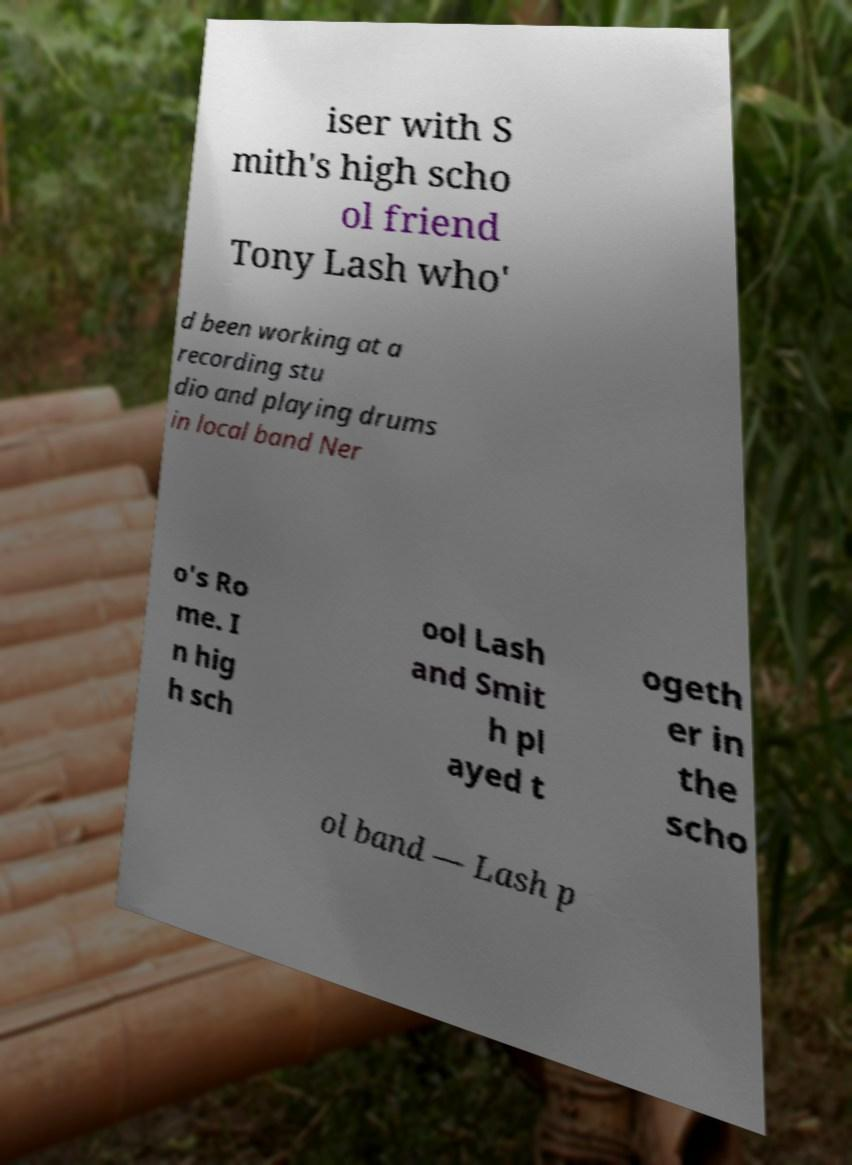Please identify and transcribe the text found in this image. iser with S mith's high scho ol friend Tony Lash who' d been working at a recording stu dio and playing drums in local band Ner o's Ro me. I n hig h sch ool Lash and Smit h pl ayed t ogeth er in the scho ol band — Lash p 